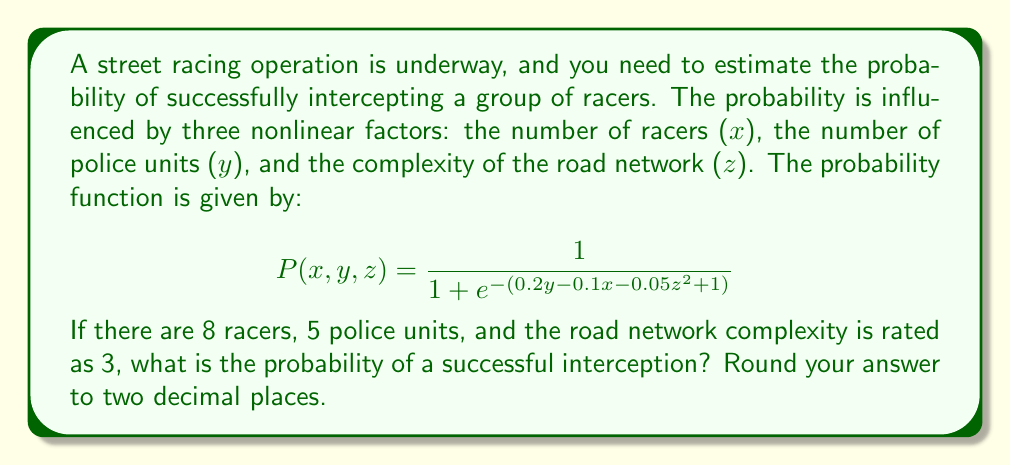Could you help me with this problem? To solve this problem, we'll follow these steps:

1) Identify the given values:
   x (number of racers) = 8
   y (number of police units) = 5
   z (road network complexity) = 3

2) Substitute these values into the probability function:

   $$P(8,5,3) = \frac{1}{1 + e^{-(0.2(5) - 0.1(8) - 0.05(3)^2 + 1)}}$$

3) Simplify the expression inside the exponential:
   
   $$0.2(5) - 0.1(8) - 0.05(3)^2 + 1$$
   $$= 1 - 0.8 - 0.45 + 1$$
   $$= 0.75$$

4) Now our equation looks like:

   $$P(8,5,3) = \frac{1}{1 + e^{-0.75}}$$

5) Calculate $e^{-0.75}$:
   
   $$e^{-0.75} \approx 0.4724$$

6) Substitute this value:

   $$P(8,5,3) = \frac{1}{1 + 0.4724}$$

7) Perform the division:

   $$P(8,5,3) = \frac{1}{1.4724} \approx 0.6792$$

8) Round to two decimal places:

   $$P(8,5,3) \approx 0.68$$

Thus, the probability of a successful interception is approximately 0.68 or 68%.
Answer: 0.68 